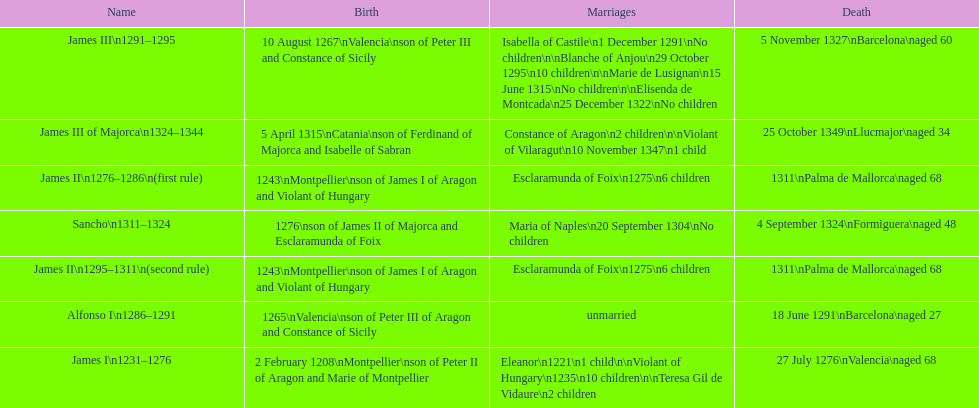How many of these monarchs died before the age of 65? 4. 